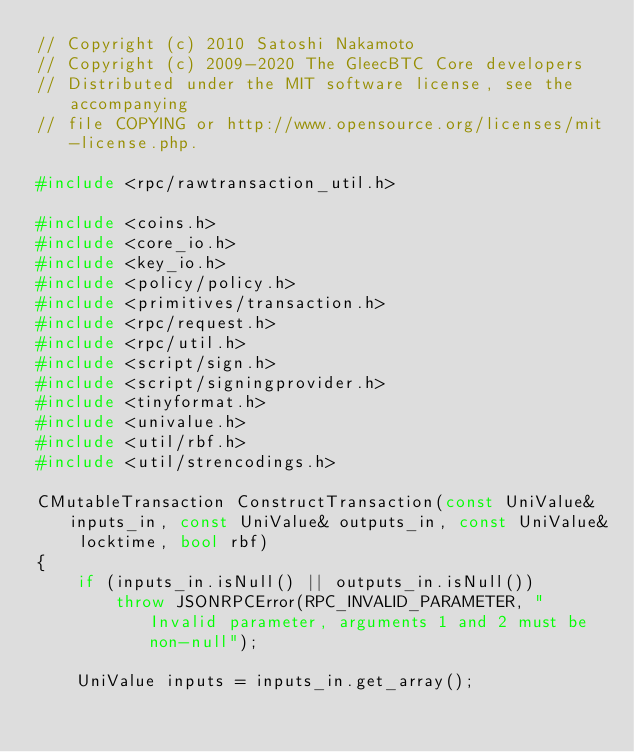<code> <loc_0><loc_0><loc_500><loc_500><_C++_>// Copyright (c) 2010 Satoshi Nakamoto
// Copyright (c) 2009-2020 The GleecBTC Core developers
// Distributed under the MIT software license, see the accompanying
// file COPYING or http://www.opensource.org/licenses/mit-license.php.

#include <rpc/rawtransaction_util.h>

#include <coins.h>
#include <core_io.h>
#include <key_io.h>
#include <policy/policy.h>
#include <primitives/transaction.h>
#include <rpc/request.h>
#include <rpc/util.h>
#include <script/sign.h>
#include <script/signingprovider.h>
#include <tinyformat.h>
#include <univalue.h>
#include <util/rbf.h>
#include <util/strencodings.h>

CMutableTransaction ConstructTransaction(const UniValue& inputs_in, const UniValue& outputs_in, const UniValue& locktime, bool rbf)
{
    if (inputs_in.isNull() || outputs_in.isNull())
        throw JSONRPCError(RPC_INVALID_PARAMETER, "Invalid parameter, arguments 1 and 2 must be non-null");

    UniValue inputs = inputs_in.get_array();</code> 